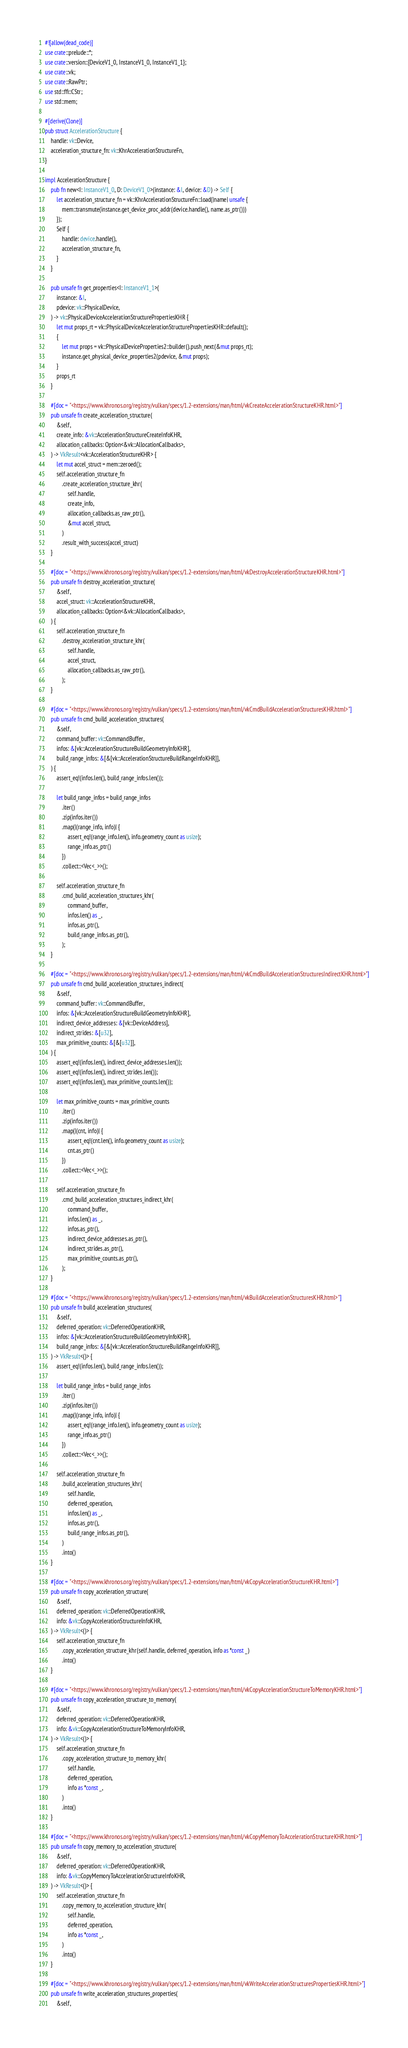<code> <loc_0><loc_0><loc_500><loc_500><_Rust_>#![allow(dead_code)]
use crate::prelude::*;
use crate::version::{DeviceV1_0, InstanceV1_0, InstanceV1_1};
use crate::vk;
use crate::RawPtr;
use std::ffi::CStr;
use std::mem;

#[derive(Clone)]
pub struct AccelerationStructure {
    handle: vk::Device,
    acceleration_structure_fn: vk::KhrAccelerationStructureFn,
}

impl AccelerationStructure {
    pub fn new<I: InstanceV1_0, D: DeviceV1_0>(instance: &I, device: &D) -> Self {
        let acceleration_structure_fn = vk::KhrAccelerationStructureFn::load(|name| unsafe {
            mem::transmute(instance.get_device_proc_addr(device.handle(), name.as_ptr()))
        });
        Self {
            handle: device.handle(),
            acceleration_structure_fn,
        }
    }

    pub unsafe fn get_properties<I: InstanceV1_1>(
        instance: &I,
        pdevice: vk::PhysicalDevice,
    ) -> vk::PhysicalDeviceAccelerationStructurePropertiesKHR {
        let mut props_rt = vk::PhysicalDeviceAccelerationStructurePropertiesKHR::default();
        {
            let mut props = vk::PhysicalDeviceProperties2::builder().push_next(&mut props_rt);
            instance.get_physical_device_properties2(pdevice, &mut props);
        }
        props_rt
    }

    #[doc = "<https://www.khronos.org/registry/vulkan/specs/1.2-extensions/man/html/vkCreateAccelerationStructureKHR.html>"]
    pub unsafe fn create_acceleration_structure(
        &self,
        create_info: &vk::AccelerationStructureCreateInfoKHR,
        allocation_callbacks: Option<&vk::AllocationCallbacks>,
    ) -> VkResult<vk::AccelerationStructureKHR> {
        let mut accel_struct = mem::zeroed();
        self.acceleration_structure_fn
            .create_acceleration_structure_khr(
                self.handle,
                create_info,
                allocation_callbacks.as_raw_ptr(),
                &mut accel_struct,
            )
            .result_with_success(accel_struct)
    }

    #[doc = "<https://www.khronos.org/registry/vulkan/specs/1.2-extensions/man/html/vkDestroyAccelerationStructureKHR.html>"]
    pub unsafe fn destroy_acceleration_structure(
        &self,
        accel_struct: vk::AccelerationStructureKHR,
        allocation_callbacks: Option<&vk::AllocationCallbacks>,
    ) {
        self.acceleration_structure_fn
            .destroy_acceleration_structure_khr(
                self.handle,
                accel_struct,
                allocation_callbacks.as_raw_ptr(),
            );
    }

    #[doc = "<https://www.khronos.org/registry/vulkan/specs/1.2-extensions/man/html/vkCmdBuildAccelerationStructuresKHR.html>"]
    pub unsafe fn cmd_build_acceleration_structures(
        &self,
        command_buffer: vk::CommandBuffer,
        infos: &[vk::AccelerationStructureBuildGeometryInfoKHR],
        build_range_infos: &[&[vk::AccelerationStructureBuildRangeInfoKHR]],
    ) {
        assert_eq!(infos.len(), build_range_infos.len());

        let build_range_infos = build_range_infos
            .iter()
            .zip(infos.iter())
            .map(|(range_info, info)| {
                assert_eq!(range_info.len(), info.geometry_count as usize);
                range_info.as_ptr()
            })
            .collect::<Vec<_>>();

        self.acceleration_structure_fn
            .cmd_build_acceleration_structures_khr(
                command_buffer,
                infos.len() as _,
                infos.as_ptr(),
                build_range_infos.as_ptr(),
            );
    }

    #[doc = "<https://www.khronos.org/registry/vulkan/specs/1.2-extensions/man/html/vkCmdBuildAccelerationStructuresIndirectKHR.html>"]
    pub unsafe fn cmd_build_acceleration_structures_indirect(
        &self,
        command_buffer: vk::CommandBuffer,
        infos: &[vk::AccelerationStructureBuildGeometryInfoKHR],
        indirect_device_addresses: &[vk::DeviceAddress],
        indirect_strides: &[u32],
        max_primitive_counts: &[&[u32]],
    ) {
        assert_eq!(infos.len(), indirect_device_addresses.len());
        assert_eq!(infos.len(), indirect_strides.len());
        assert_eq!(infos.len(), max_primitive_counts.len());

        let max_primitive_counts = max_primitive_counts
            .iter()
            .zip(infos.iter())
            .map(|(cnt, info)| {
                assert_eq!(cnt.len(), info.geometry_count as usize);
                cnt.as_ptr()
            })
            .collect::<Vec<_>>();

        self.acceleration_structure_fn
            .cmd_build_acceleration_structures_indirect_khr(
                command_buffer,
                infos.len() as _,
                infos.as_ptr(),
                indirect_device_addresses.as_ptr(),
                indirect_strides.as_ptr(),
                max_primitive_counts.as_ptr(),
            );
    }

    #[doc = "<https://www.khronos.org/registry/vulkan/specs/1.2-extensions/man/html/vkBuildAccelerationStructuresKHR.html>"]
    pub unsafe fn build_acceleration_structures(
        &self,
        deferred_operation: vk::DeferredOperationKHR,
        infos: &[vk::AccelerationStructureBuildGeometryInfoKHR],
        build_range_infos: &[&[vk::AccelerationStructureBuildRangeInfoKHR]],
    ) -> VkResult<()> {
        assert_eq!(infos.len(), build_range_infos.len());

        let build_range_infos = build_range_infos
            .iter()
            .zip(infos.iter())
            .map(|(range_info, info)| {
                assert_eq!(range_info.len(), info.geometry_count as usize);
                range_info.as_ptr()
            })
            .collect::<Vec<_>>();

        self.acceleration_structure_fn
            .build_acceleration_structures_khr(
                self.handle,
                deferred_operation,
                infos.len() as _,
                infos.as_ptr(),
                build_range_infos.as_ptr(),
            )
            .into()
    }

    #[doc = "<https://www.khronos.org/registry/vulkan/specs/1.2-extensions/man/html/vkCopyAccelerationStructureKHR.html>"]
    pub unsafe fn copy_acceleration_structure(
        &self,
        deferred_operation: vk::DeferredOperationKHR,
        info: &vk::CopyAccelerationStructureInfoKHR,
    ) -> VkResult<()> {
        self.acceleration_structure_fn
            .copy_acceleration_structure_khr(self.handle, deferred_operation, info as *const _)
            .into()
    }

    #[doc = "<https://www.khronos.org/registry/vulkan/specs/1.2-extensions/man/html/vkCopyAccelerationStructureToMemoryKHR.html>"]
    pub unsafe fn copy_acceleration_structure_to_memory(
        &self,
        deferred_operation: vk::DeferredOperationKHR,
        info: &vk::CopyAccelerationStructureToMemoryInfoKHR,
    ) -> VkResult<()> {
        self.acceleration_structure_fn
            .copy_acceleration_structure_to_memory_khr(
                self.handle,
                deferred_operation,
                info as *const _,
            )
            .into()
    }

    #[doc = "<https://www.khronos.org/registry/vulkan/specs/1.2-extensions/man/html/vkCopyMemoryToAccelerationStructureKHR.html>"]
    pub unsafe fn copy_memory_to_acceleration_structure(
        &self,
        deferred_operation: vk::DeferredOperationKHR,
        info: &vk::CopyMemoryToAccelerationStructureInfoKHR,
    ) -> VkResult<()> {
        self.acceleration_structure_fn
            .copy_memory_to_acceleration_structure_khr(
                self.handle,
                deferred_operation,
                info as *const _,
            )
            .into()
    }

    #[doc = "<https://www.khronos.org/registry/vulkan/specs/1.2-extensions/man/html/vkWriteAccelerationStructuresPropertiesKHR.html>"]
    pub unsafe fn write_acceleration_structures_properties(
        &self,</code> 